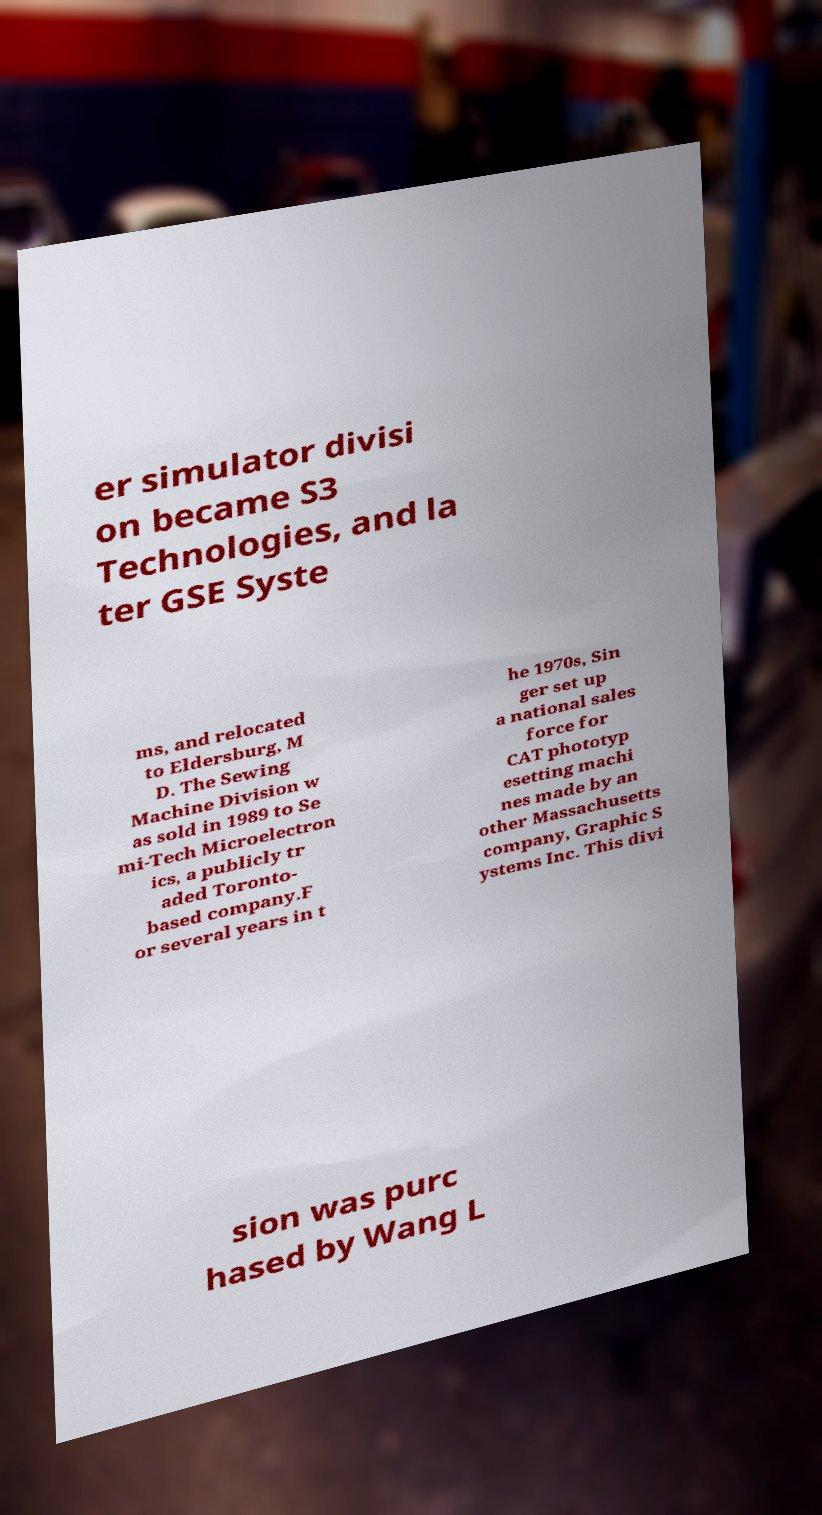Can you read and provide the text displayed in the image?This photo seems to have some interesting text. Can you extract and type it out for me? er simulator divisi on became S3 Technologies, and la ter GSE Syste ms, and relocated to Eldersburg, M D. The Sewing Machine Division w as sold in 1989 to Se mi-Tech Microelectron ics, a publicly tr aded Toronto- based company.F or several years in t he 1970s, Sin ger set up a national sales force for CAT phototyp esetting machi nes made by an other Massachusetts company, Graphic S ystems Inc. This divi sion was purc hased by Wang L 